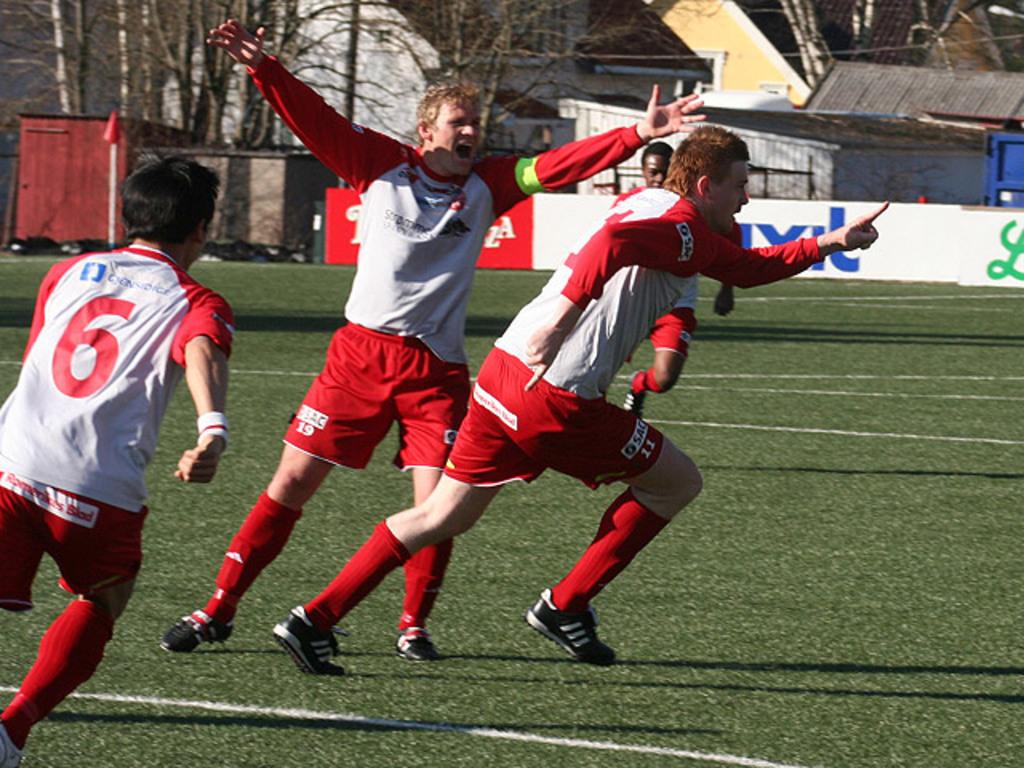How many people are in the foreground of the image? There are four men in the foreground of the image. What are the men doing in the image? The men are running on the grass. What can be seen in the background of the image? There is a banner, buildings, and trees in the background of the image. What type of wrench is being used by one of the men in the image? There is no wrench present in the image; the men are running on the grass. What kind of treatment is being administered to the trees in the background? There is no treatment being administered to the trees in the background; they are simply visible in the image. 